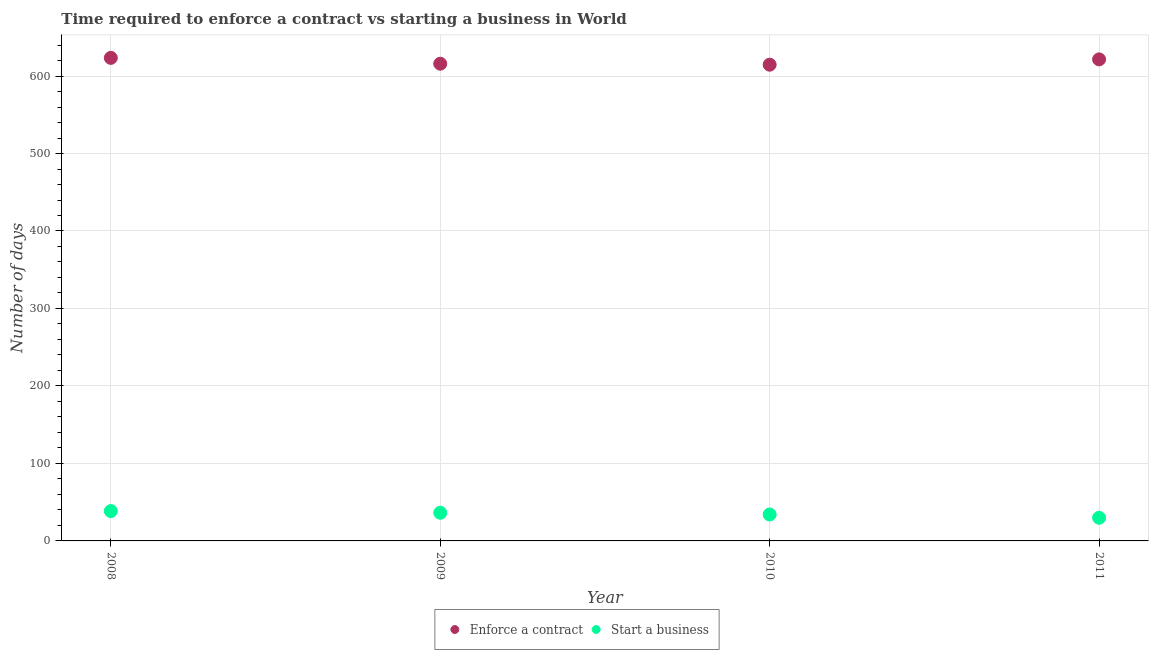How many different coloured dotlines are there?
Offer a terse response. 2. What is the number of days to start a business in 2011?
Provide a short and direct response. 29.9. Across all years, what is the maximum number of days to enforece a contract?
Offer a very short reply. 623.44. Across all years, what is the minimum number of days to enforece a contract?
Your answer should be compact. 614.64. What is the total number of days to start a business in the graph?
Offer a terse response. 138.89. What is the difference between the number of days to start a business in 2009 and that in 2011?
Keep it short and to the point. 6.46. What is the difference between the number of days to start a business in 2011 and the number of days to enforece a contract in 2008?
Ensure brevity in your answer.  -593.54. What is the average number of days to enforece a contract per year?
Keep it short and to the point. 618.87. In the year 2010, what is the difference between the number of days to start a business and number of days to enforece a contract?
Provide a short and direct response. -580.54. What is the ratio of the number of days to start a business in 2008 to that in 2011?
Your answer should be very brief. 1.29. Is the difference between the number of days to enforece a contract in 2008 and 2010 greater than the difference between the number of days to start a business in 2008 and 2010?
Your response must be concise. Yes. What is the difference between the highest and the second highest number of days to enforece a contract?
Your answer should be very brief. 1.94. What is the difference between the highest and the lowest number of days to start a business?
Offer a very short reply. 8.62. In how many years, is the number of days to enforece a contract greater than the average number of days to enforece a contract taken over all years?
Your response must be concise. 2. Is the number of days to start a business strictly greater than the number of days to enforece a contract over the years?
Your response must be concise. No. How many dotlines are there?
Ensure brevity in your answer.  2. What is the difference between two consecutive major ticks on the Y-axis?
Your answer should be very brief. 100. Are the values on the major ticks of Y-axis written in scientific E-notation?
Ensure brevity in your answer.  No. Where does the legend appear in the graph?
Make the answer very short. Bottom center. What is the title of the graph?
Provide a succinct answer. Time required to enforce a contract vs starting a business in World. Does "Under five" appear as one of the legend labels in the graph?
Your answer should be compact. No. What is the label or title of the X-axis?
Provide a succinct answer. Year. What is the label or title of the Y-axis?
Give a very brief answer. Number of days. What is the Number of days in Enforce a contract in 2008?
Provide a short and direct response. 623.44. What is the Number of days of Start a business in 2008?
Give a very brief answer. 38.53. What is the Number of days of Enforce a contract in 2009?
Offer a very short reply. 615.9. What is the Number of days in Start a business in 2009?
Provide a succinct answer. 36.36. What is the Number of days in Enforce a contract in 2010?
Offer a terse response. 614.64. What is the Number of days of Start a business in 2010?
Provide a short and direct response. 34.1. What is the Number of days in Enforce a contract in 2011?
Provide a short and direct response. 621.51. What is the Number of days in Start a business in 2011?
Your answer should be compact. 29.9. Across all years, what is the maximum Number of days in Enforce a contract?
Provide a succinct answer. 623.44. Across all years, what is the maximum Number of days in Start a business?
Provide a short and direct response. 38.53. Across all years, what is the minimum Number of days in Enforce a contract?
Offer a terse response. 614.64. Across all years, what is the minimum Number of days in Start a business?
Provide a short and direct response. 29.9. What is the total Number of days in Enforce a contract in the graph?
Keep it short and to the point. 2475.49. What is the total Number of days of Start a business in the graph?
Your answer should be compact. 138.89. What is the difference between the Number of days in Enforce a contract in 2008 and that in 2009?
Offer a terse response. 7.54. What is the difference between the Number of days in Start a business in 2008 and that in 2009?
Give a very brief answer. 2.17. What is the difference between the Number of days of Enforce a contract in 2008 and that in 2010?
Your response must be concise. 8.8. What is the difference between the Number of days of Start a business in 2008 and that in 2010?
Ensure brevity in your answer.  4.42. What is the difference between the Number of days in Enforce a contract in 2008 and that in 2011?
Your answer should be compact. 1.94. What is the difference between the Number of days in Start a business in 2008 and that in 2011?
Your answer should be compact. 8.62. What is the difference between the Number of days in Enforce a contract in 2009 and that in 2010?
Keep it short and to the point. 1.26. What is the difference between the Number of days in Start a business in 2009 and that in 2010?
Your answer should be very brief. 2.26. What is the difference between the Number of days in Enforce a contract in 2009 and that in 2011?
Make the answer very short. -5.6. What is the difference between the Number of days in Start a business in 2009 and that in 2011?
Give a very brief answer. 6.46. What is the difference between the Number of days in Enforce a contract in 2010 and that in 2011?
Ensure brevity in your answer.  -6.87. What is the difference between the Number of days in Start a business in 2010 and that in 2011?
Give a very brief answer. 4.2. What is the difference between the Number of days in Enforce a contract in 2008 and the Number of days in Start a business in 2009?
Your answer should be very brief. 587.09. What is the difference between the Number of days in Enforce a contract in 2008 and the Number of days in Start a business in 2010?
Keep it short and to the point. 589.34. What is the difference between the Number of days of Enforce a contract in 2008 and the Number of days of Start a business in 2011?
Offer a terse response. 593.54. What is the difference between the Number of days in Enforce a contract in 2009 and the Number of days in Start a business in 2010?
Ensure brevity in your answer.  581.8. What is the difference between the Number of days of Enforce a contract in 2009 and the Number of days of Start a business in 2011?
Keep it short and to the point. 586. What is the difference between the Number of days in Enforce a contract in 2010 and the Number of days in Start a business in 2011?
Offer a terse response. 584.74. What is the average Number of days in Enforce a contract per year?
Make the answer very short. 618.87. What is the average Number of days in Start a business per year?
Provide a succinct answer. 34.72. In the year 2008, what is the difference between the Number of days in Enforce a contract and Number of days in Start a business?
Give a very brief answer. 584.92. In the year 2009, what is the difference between the Number of days in Enforce a contract and Number of days in Start a business?
Your response must be concise. 579.54. In the year 2010, what is the difference between the Number of days in Enforce a contract and Number of days in Start a business?
Provide a short and direct response. 580.54. In the year 2011, what is the difference between the Number of days in Enforce a contract and Number of days in Start a business?
Give a very brief answer. 591.6. What is the ratio of the Number of days of Enforce a contract in 2008 to that in 2009?
Your response must be concise. 1.01. What is the ratio of the Number of days of Start a business in 2008 to that in 2009?
Your answer should be very brief. 1.06. What is the ratio of the Number of days of Enforce a contract in 2008 to that in 2010?
Give a very brief answer. 1.01. What is the ratio of the Number of days of Start a business in 2008 to that in 2010?
Your response must be concise. 1.13. What is the ratio of the Number of days in Enforce a contract in 2008 to that in 2011?
Your response must be concise. 1. What is the ratio of the Number of days of Start a business in 2008 to that in 2011?
Keep it short and to the point. 1.29. What is the ratio of the Number of days in Start a business in 2009 to that in 2010?
Keep it short and to the point. 1.07. What is the ratio of the Number of days in Start a business in 2009 to that in 2011?
Ensure brevity in your answer.  1.22. What is the ratio of the Number of days in Enforce a contract in 2010 to that in 2011?
Your answer should be very brief. 0.99. What is the ratio of the Number of days of Start a business in 2010 to that in 2011?
Your answer should be compact. 1.14. What is the difference between the highest and the second highest Number of days of Enforce a contract?
Offer a terse response. 1.94. What is the difference between the highest and the second highest Number of days in Start a business?
Your answer should be very brief. 2.17. What is the difference between the highest and the lowest Number of days in Enforce a contract?
Give a very brief answer. 8.8. What is the difference between the highest and the lowest Number of days in Start a business?
Your answer should be compact. 8.62. 